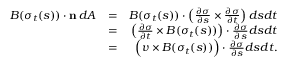Convert formula to latex. <formula><loc_0><loc_0><loc_500><loc_500>\begin{array} { r l r } { B ( \sigma _ { t } ( s ) ) \cdot n \, d A } & { = } & { B ( \sigma _ { t } ( s ) ) \cdot \left ( \frac { \partial \sigma } { \partial s } \times \frac { \partial \sigma } { \partial t } \right ) d s d t } \\ & { = } & { \left ( \frac { \partial \sigma } { \partial t } \times B ( \sigma _ { t } ( s ) ) \right ) \cdot \frac { \partial \sigma } { \partial s } d s d t } \\ & { = } & { \left ( v \times B ( \sigma _ { t } ( s ) ) \right ) \cdot \frac { \partial \sigma } { \partial s } d s d t . } \end{array}</formula> 